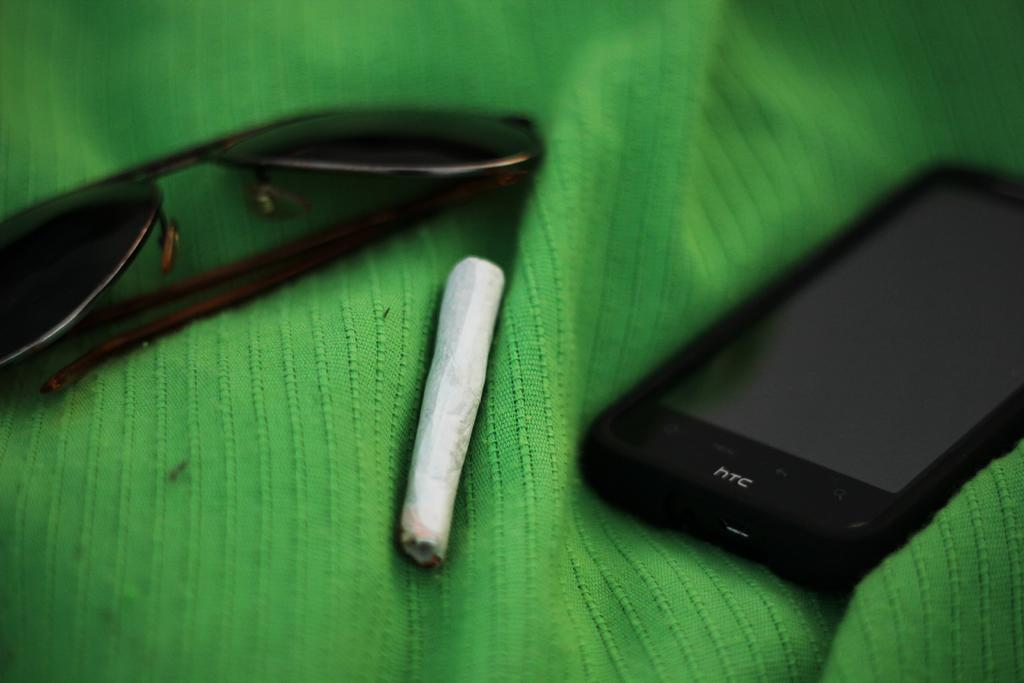<image>
Present a compact description of the photo's key features. A green cloth with htc cellphone and sunglasses laying on it. 